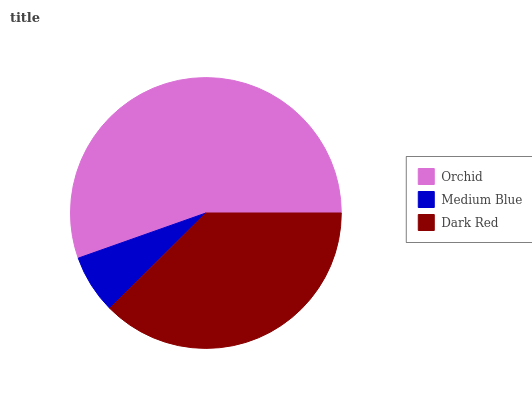Is Medium Blue the minimum?
Answer yes or no. Yes. Is Orchid the maximum?
Answer yes or no. Yes. Is Dark Red the minimum?
Answer yes or no. No. Is Dark Red the maximum?
Answer yes or no. No. Is Dark Red greater than Medium Blue?
Answer yes or no. Yes. Is Medium Blue less than Dark Red?
Answer yes or no. Yes. Is Medium Blue greater than Dark Red?
Answer yes or no. No. Is Dark Red less than Medium Blue?
Answer yes or no. No. Is Dark Red the high median?
Answer yes or no. Yes. Is Dark Red the low median?
Answer yes or no. Yes. Is Medium Blue the high median?
Answer yes or no. No. Is Orchid the low median?
Answer yes or no. No. 